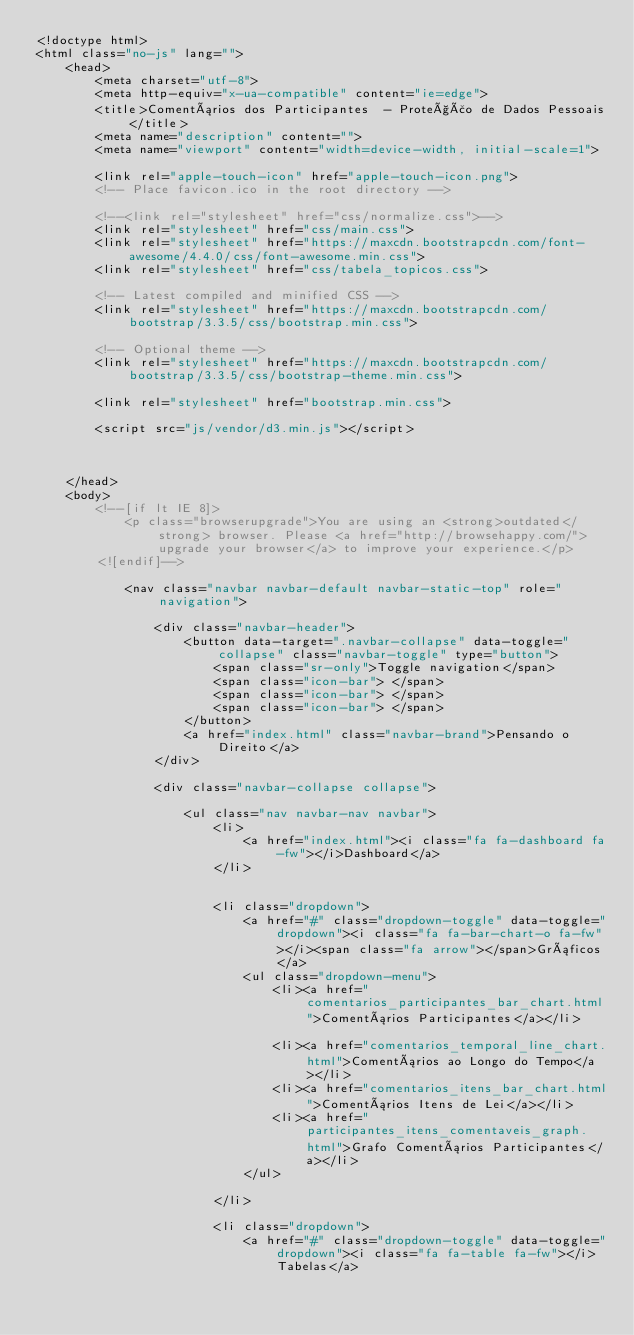<code> <loc_0><loc_0><loc_500><loc_500><_HTML_><!doctype html>
<html class="no-js" lang="">
    <head>
        <meta charset="utf-8">
        <meta http-equiv="x-ua-compatible" content="ie=edge">
        <title>Comentários dos Participantes  - Proteção de Dados Pessoais</title>
        <meta name="description" content="">
        <meta name="viewport" content="width=device-width, initial-scale=1">

        <link rel="apple-touch-icon" href="apple-touch-icon.png">
        <!-- Place favicon.ico in the root directory -->

        <!--<link rel="stylesheet" href="css/normalize.css">-->
        <link rel="stylesheet" href="css/main.css">
        <link rel="stylesheet" href="https://maxcdn.bootstrapcdn.com/font-awesome/4.4.0/css/font-awesome.min.css">
        <link rel="stylesheet" href="css/tabela_topicos.css">
        
        <!-- Latest compiled and minified CSS -->
		<link rel="stylesheet" href="https://maxcdn.bootstrapcdn.com/bootstrap/3.3.5/css/bootstrap.min.css">

		<!-- Optional theme -->
		<link rel="stylesheet" href="https://maxcdn.bootstrapcdn.com/bootstrap/3.3.5/css/bootstrap-theme.min.css">
		
		<link rel="stylesheet" href="bootstrap.min.css">
		        
        <script src="js/vendor/d3.min.js"></script>
        
        

    </head>
    <body>
        <!--[if lt IE 8]>
            <p class="browserupgrade">You are using an <strong>outdated</strong> browser. Please <a href="http://browsehappy.com/">upgrade your browser</a> to improve your experience.</p>
        <![endif]-->
		
		   	<nav class="navbar navbar-default navbar-static-top" role="navigation">
        		
        		<div class="navbar-header">
                	<button data-target=".navbar-collapse" data-toggle="collapse" class="navbar-toggle" type="button">
                    	<span class="sr-only">Toggle navigation</span>
                    	<span class="icon-bar"> </span>
                    	<span class="icon-bar"> </span>
                    	<span class="icon-bar"> </span>
                	</button>
                	<a href="index.html" class="navbar-brand">Pensando o Direito</a>
            	</div>
            	
            	<div class="navbar-collapse collapse">
            		
            		<ul class="nav navbar-nav navbar">
            			<li> 
            				<a href="index.html"><i class="fa fa-dashboard fa-fw"></i>Dashboard</a>
            			</li>
            			
            			
            			<li class="dropdown"> 
            				<a href="#" class="dropdown-toggle" data-toggle="dropdown"><i class="fa fa-bar-chart-o fa-fw"></i><span class="fa arrow"></span>Gráficos</a>
            				<ul class="dropdown-menu">
								<li><a href="comentarios_participantes_bar_chart.html">Comentários Participantes</a></li>            					
            					<li><a href="comentarios_temporal_line_chart.html">Comentários ao Longo do Tempo</a></li>
            					<li><a href="comentarios_itens_bar_chart.html">Comentários Itens de Lei</a></li>
            					<li><a href="participantes_itens_comentaveis_graph.html">Grafo Comentários Participantes</a></li>
            				</ul>
            			
            			</li>
            			
            			<li class="dropdown">
            				<a href="#" class="dropdown-toggle" data-toggle="dropdown"><i class="fa fa-table fa-fw"></i>Tabelas</a></code> 